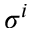Convert formula to latex. <formula><loc_0><loc_0><loc_500><loc_500>\sigma ^ { i }</formula> 